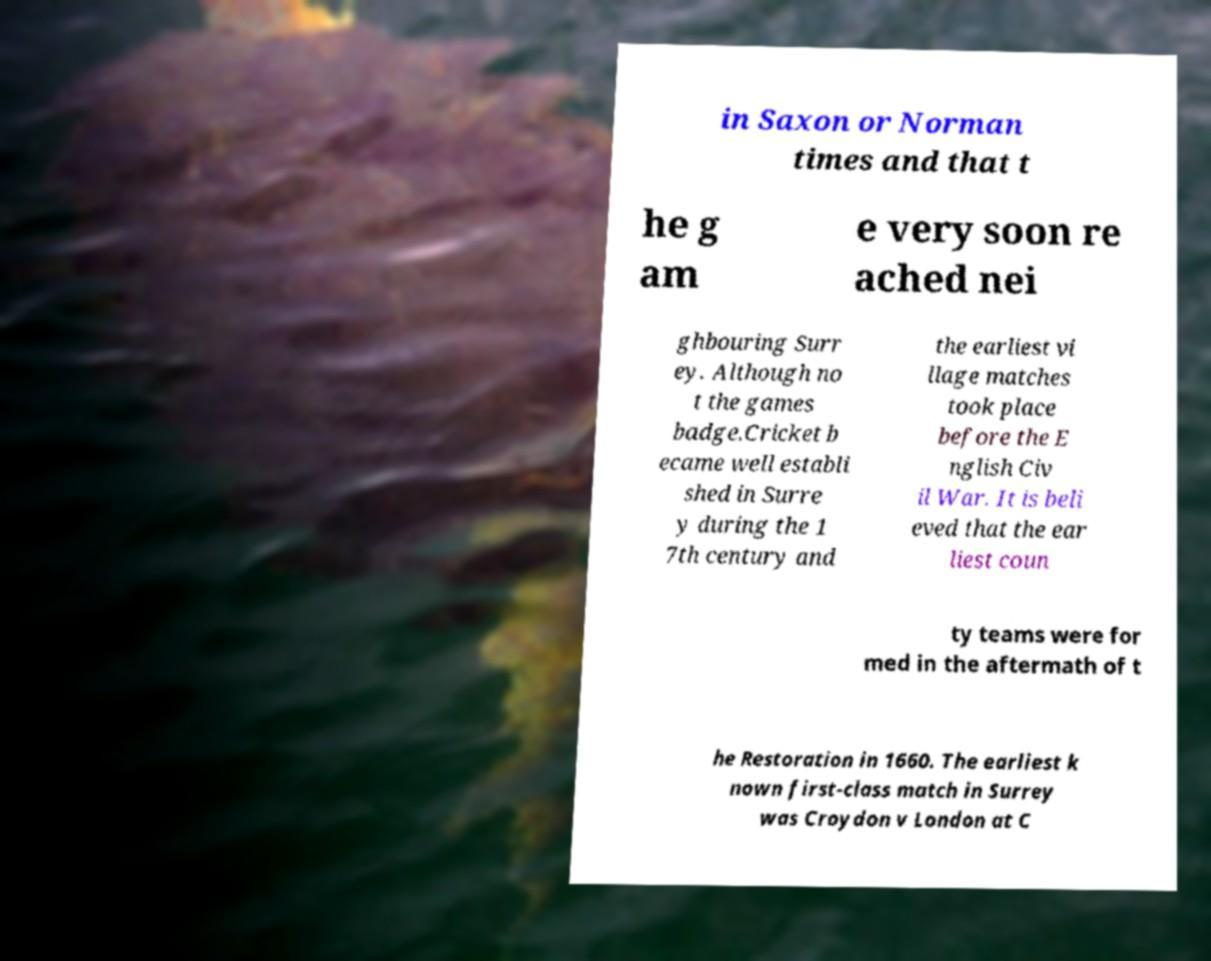Could you assist in decoding the text presented in this image and type it out clearly? in Saxon or Norman times and that t he g am e very soon re ached nei ghbouring Surr ey. Although no t the games badge.Cricket b ecame well establi shed in Surre y during the 1 7th century and the earliest vi llage matches took place before the E nglish Civ il War. It is beli eved that the ear liest coun ty teams were for med in the aftermath of t he Restoration in 1660. The earliest k nown first-class match in Surrey was Croydon v London at C 